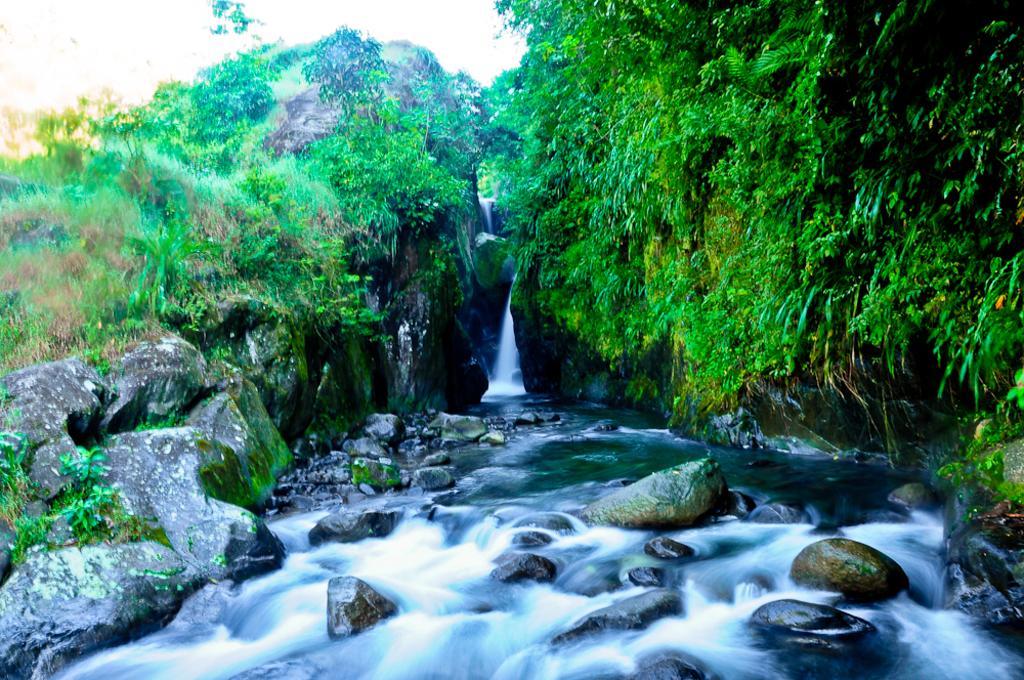How would you summarize this image in a sentence or two? I can see this is an edited image. There are rocks, hills, plants, trees and also there is water. 